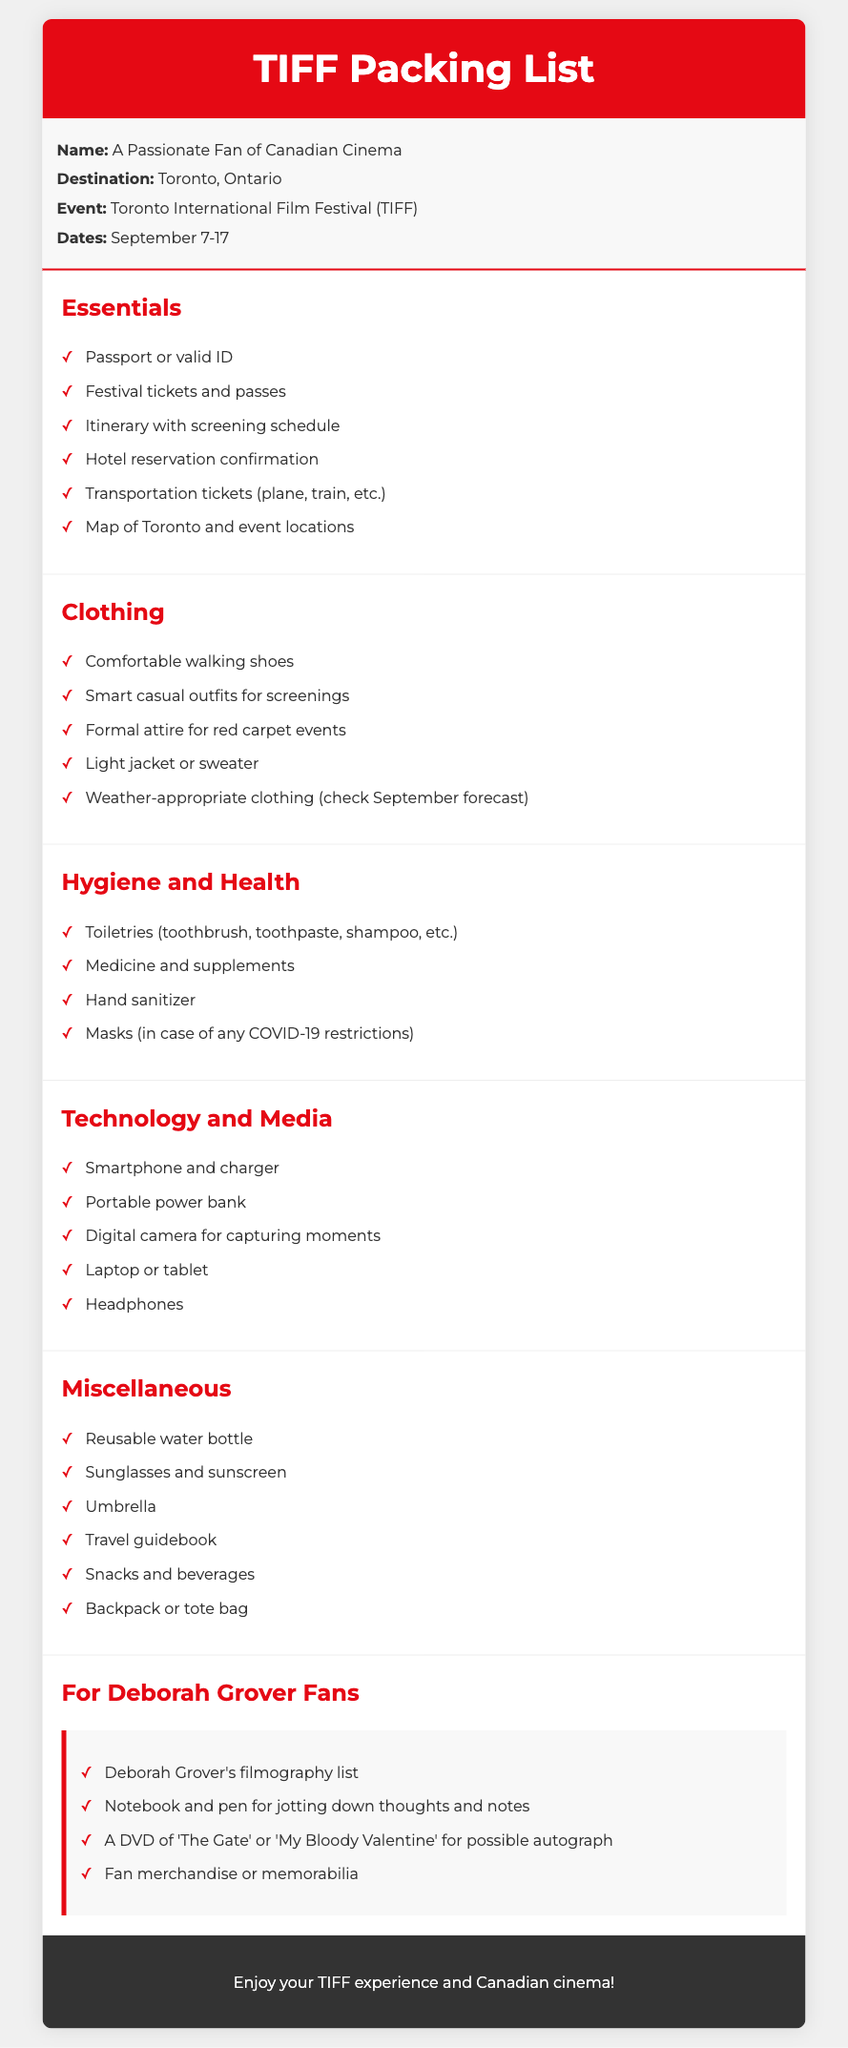What are the dates for TIFF? The document specifies the event dates for TIFF as September 7-17.
Answer: September 7-17 What should I pack for hygiene and health? The hygiene and health section includes important items you should bring, such as toiletries and medicine.
Answer: Toiletries, medicine What type of shoes should I bring? The document indicates that comfortable walking shoes are essential for the event.
Answer: Comfortable walking shoes What special items are suggested for Deborah Grover fans? The document lists specific items of interest to Deborah Grover fans under a dedicated section.
Answer: Filmography list What is one of the miscellaneous items to bring? The miscellaneous section includes various useful items, one being a reusable water bottle.
Answer: Reusable water bottle What is the color of the header? The header of the packing list uses a specific bold color for its background.
Answer: Red 